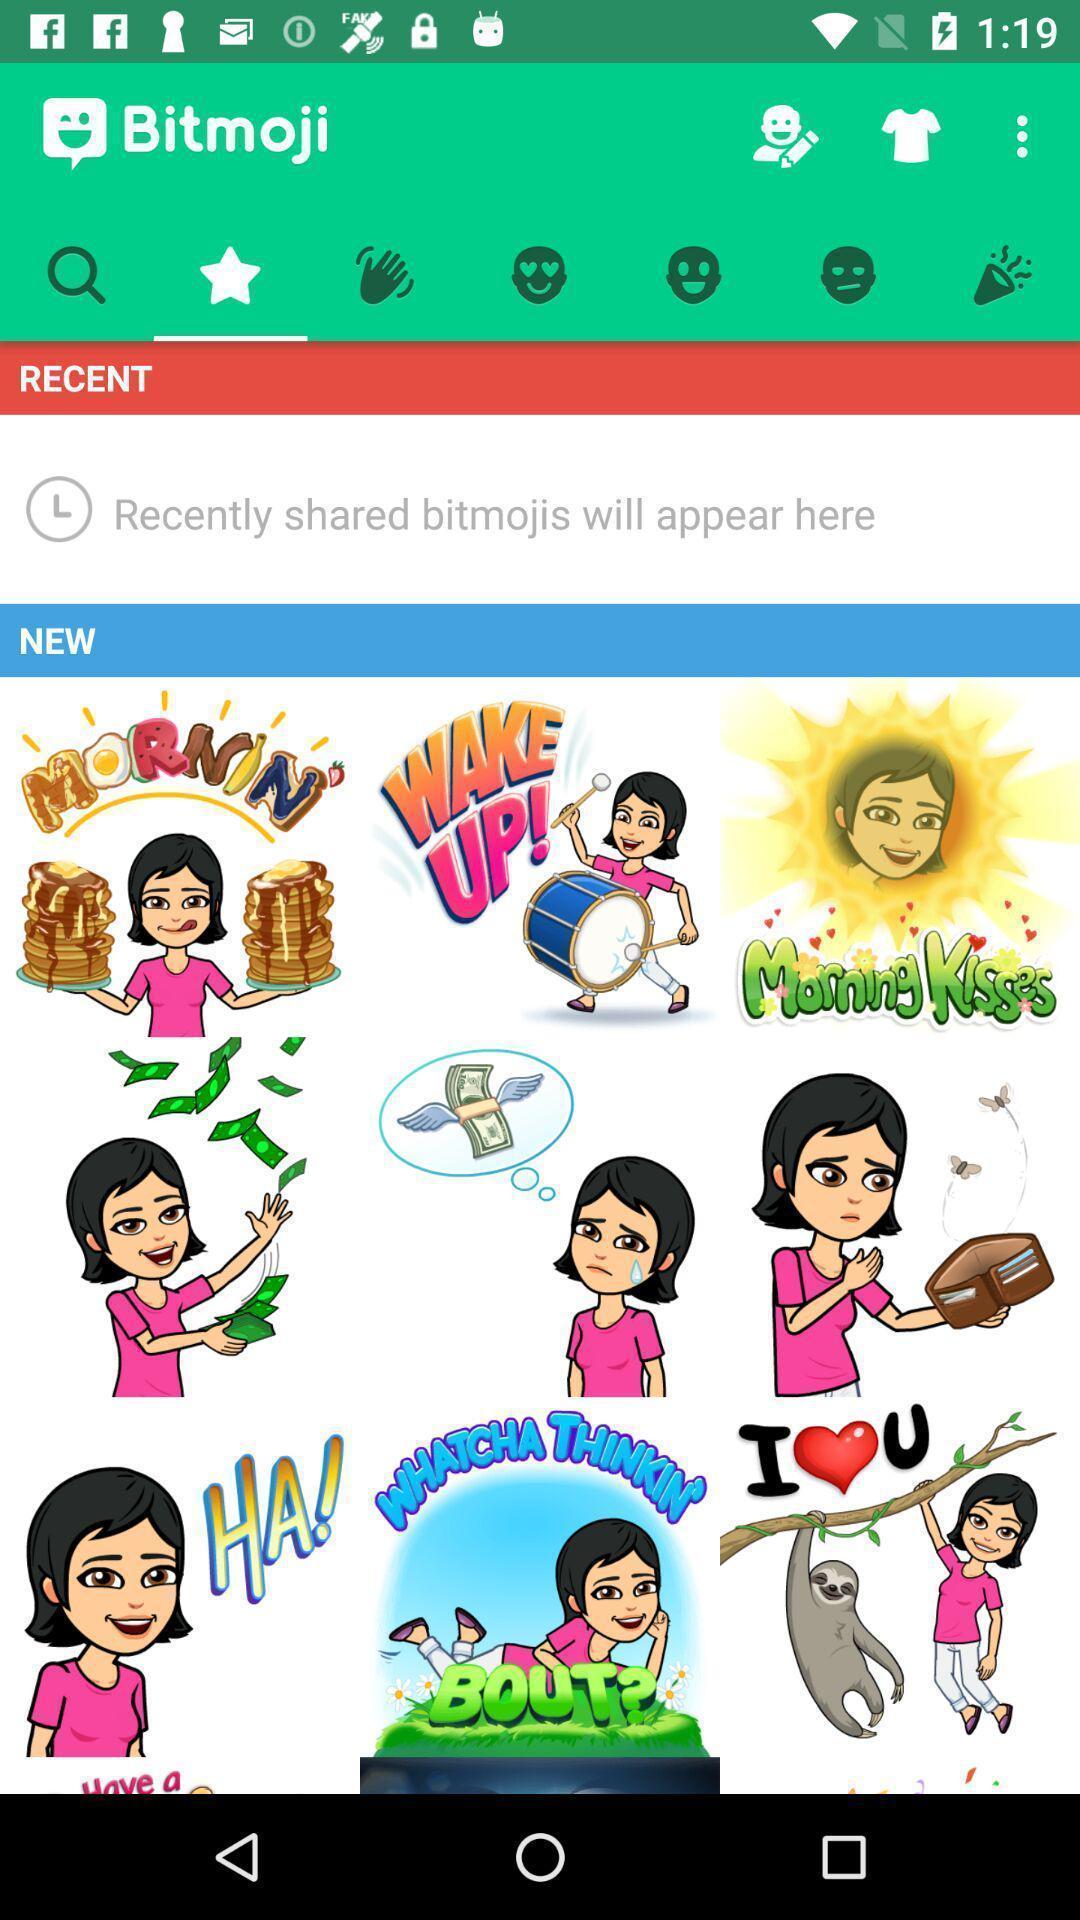What can you discern from this picture? Page displaying with different stickers options. 